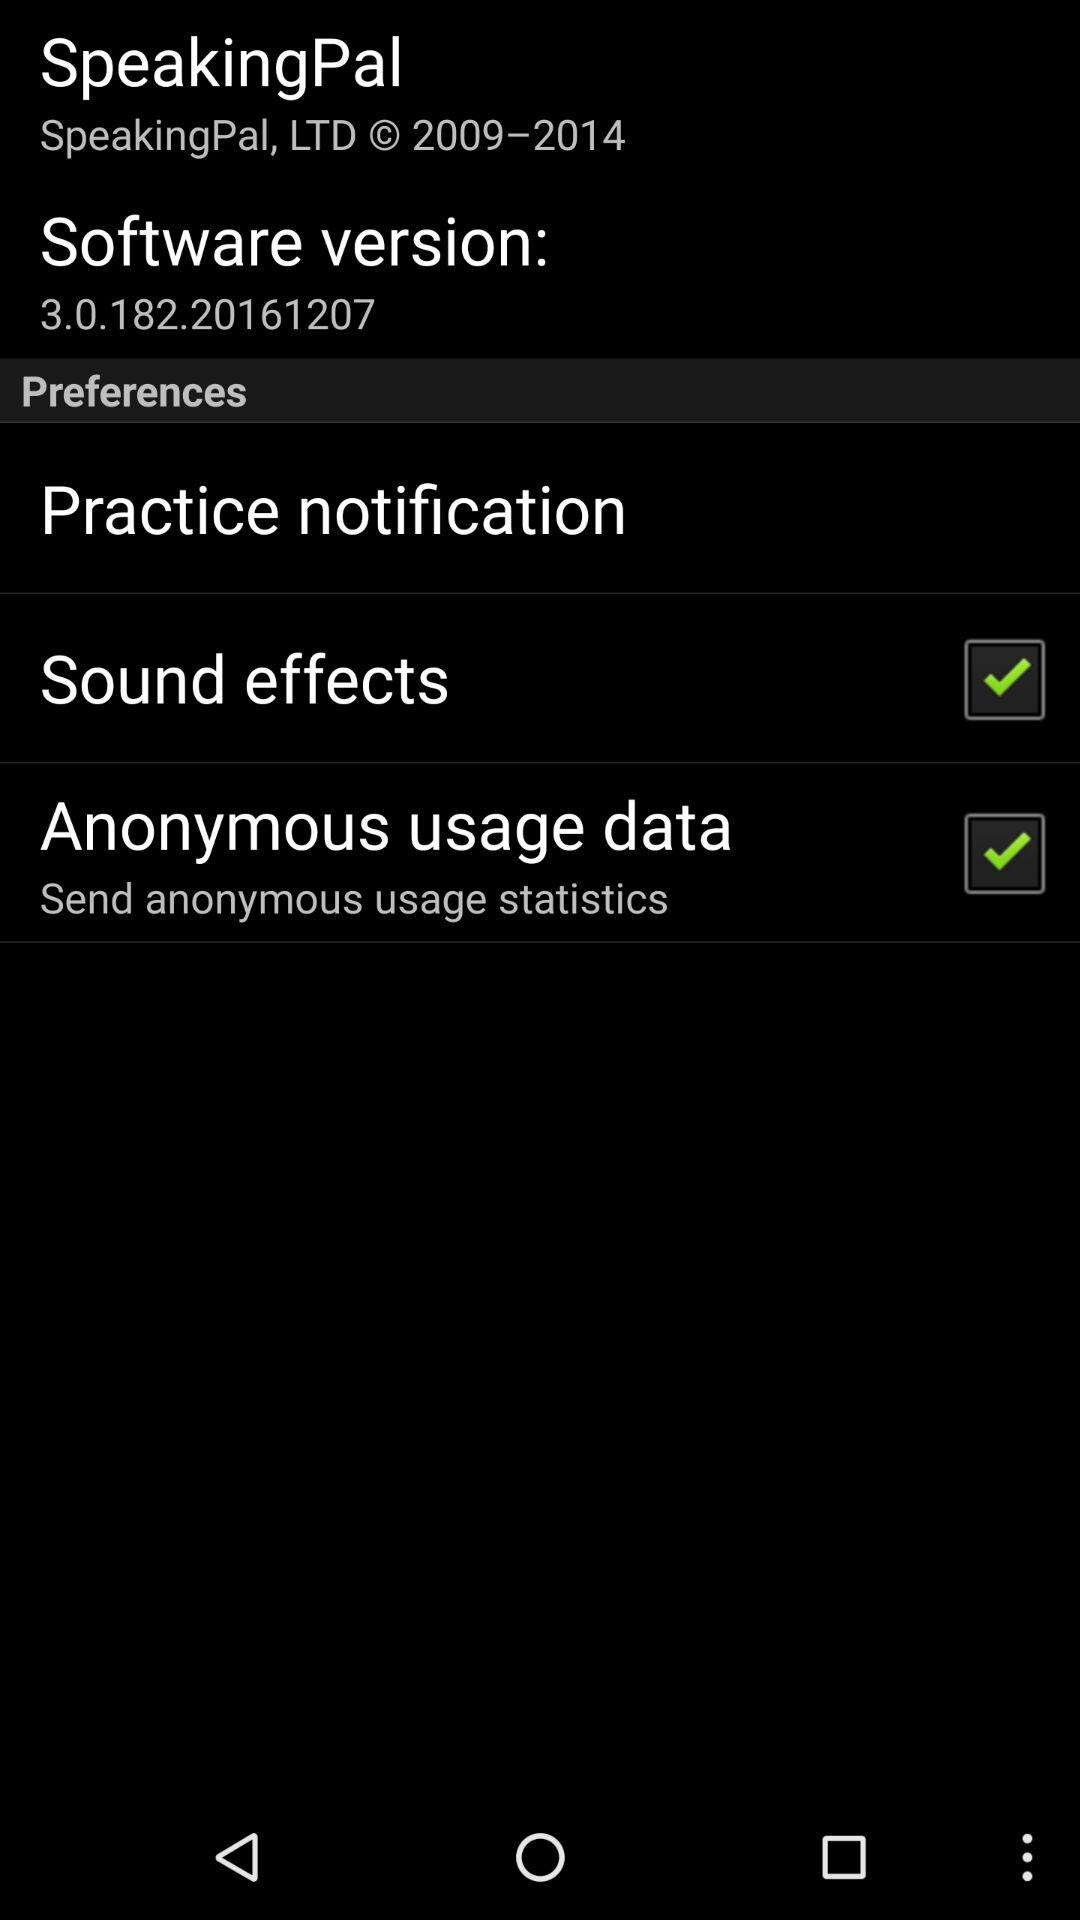What is the status of anonymous usage data? The status of anonymous usage data is "on". 